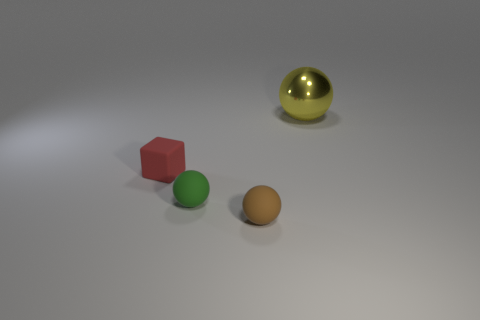The tiny green thing that is the same material as the tiny brown object is what shape?
Your answer should be very brief. Sphere. Do the brown sphere to the right of the tiny green rubber thing and the sphere behind the green sphere have the same size?
Make the answer very short. No. There is a small object in front of the green object; what shape is it?
Provide a short and direct response. Sphere. What is the color of the small cube?
Your answer should be compact. Red. There is a yellow ball; is it the same size as the rubber ball to the left of the brown matte ball?
Keep it short and to the point. No. What number of metal things are either small brown cubes or tiny spheres?
Your answer should be very brief. 0. Are there any other things that are made of the same material as the yellow thing?
Ensure brevity in your answer.  No. There is a tiny block; is it the same color as the ball that is on the right side of the tiny brown ball?
Your answer should be compact. No. The red thing has what shape?
Your answer should be very brief. Cube. What is the size of the matte thing to the left of the tiny rubber sphere that is behind the small thing right of the green matte thing?
Your response must be concise. Small. 